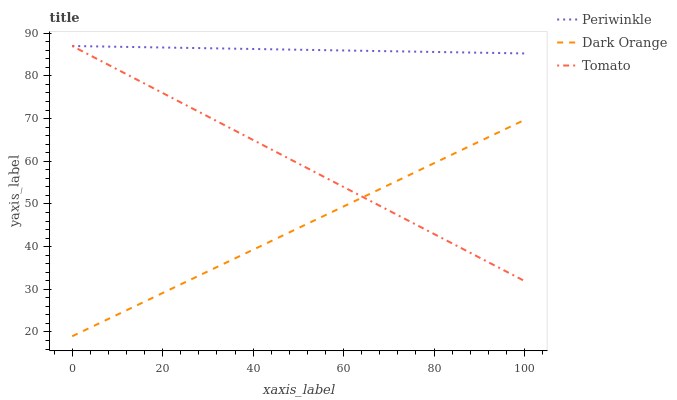Does Dark Orange have the minimum area under the curve?
Answer yes or no. Yes. Does Periwinkle have the maximum area under the curve?
Answer yes or no. Yes. Does Periwinkle have the minimum area under the curve?
Answer yes or no. No. Does Dark Orange have the maximum area under the curve?
Answer yes or no. No. Is Dark Orange the smoothest?
Answer yes or no. Yes. Is Periwinkle the roughest?
Answer yes or no. Yes. Is Periwinkle the smoothest?
Answer yes or no. No. Is Dark Orange the roughest?
Answer yes or no. No. Does Dark Orange have the lowest value?
Answer yes or no. Yes. Does Periwinkle have the lowest value?
Answer yes or no. No. Does Periwinkle have the highest value?
Answer yes or no. Yes. Does Dark Orange have the highest value?
Answer yes or no. No. Is Dark Orange less than Periwinkle?
Answer yes or no. Yes. Is Periwinkle greater than Dark Orange?
Answer yes or no. Yes. Does Dark Orange intersect Tomato?
Answer yes or no. Yes. Is Dark Orange less than Tomato?
Answer yes or no. No. Is Dark Orange greater than Tomato?
Answer yes or no. No. Does Dark Orange intersect Periwinkle?
Answer yes or no. No. 